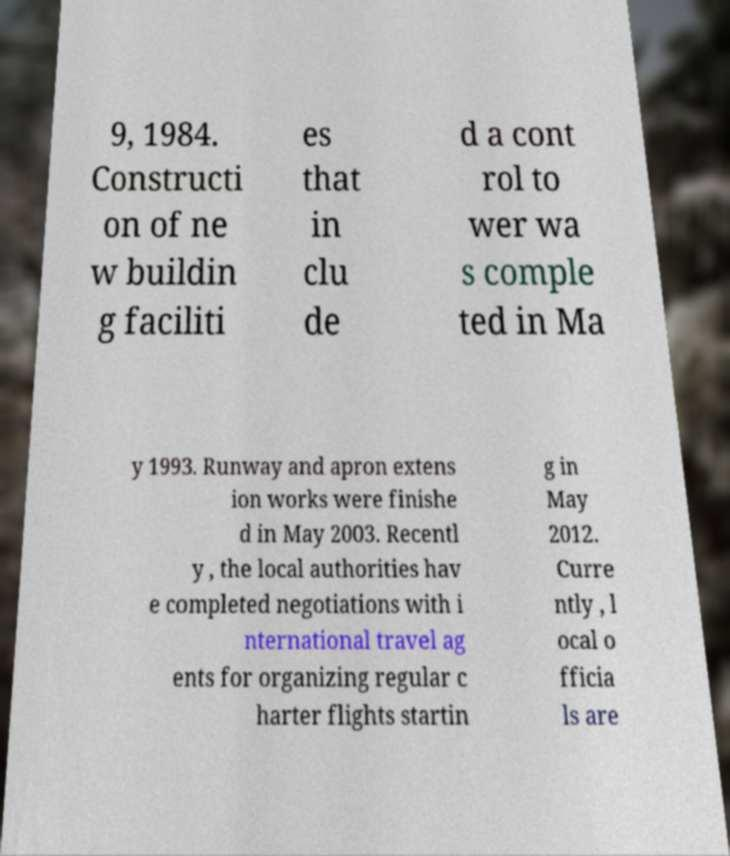What messages or text are displayed in this image? I need them in a readable, typed format. 9, 1984. Constructi on of ne w buildin g faciliti es that in clu de d a cont rol to wer wa s comple ted in Ma y 1993. Runway and apron extens ion works were finishe d in May 2003. Recentl y , the local authorities hav e completed negotiations with i nternational travel ag ents for organizing regular c harter flights startin g in May 2012. Curre ntly , l ocal o fficia ls are 